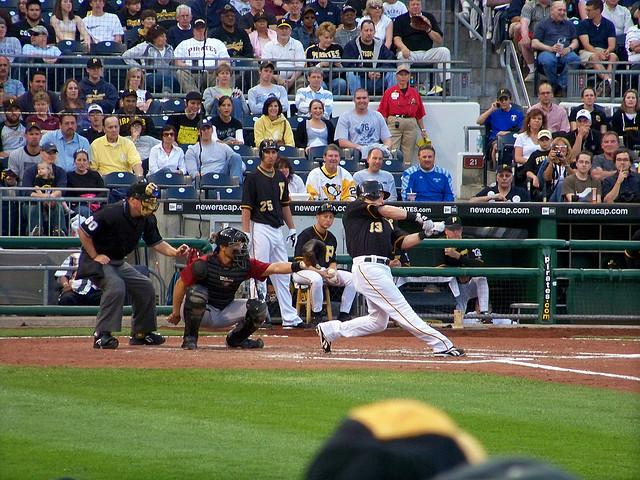Which former teammate of Chipper Jones is standing in the on-deck circle? Please explain your reasoning. adam laroche. The number shown is that athletes number. 